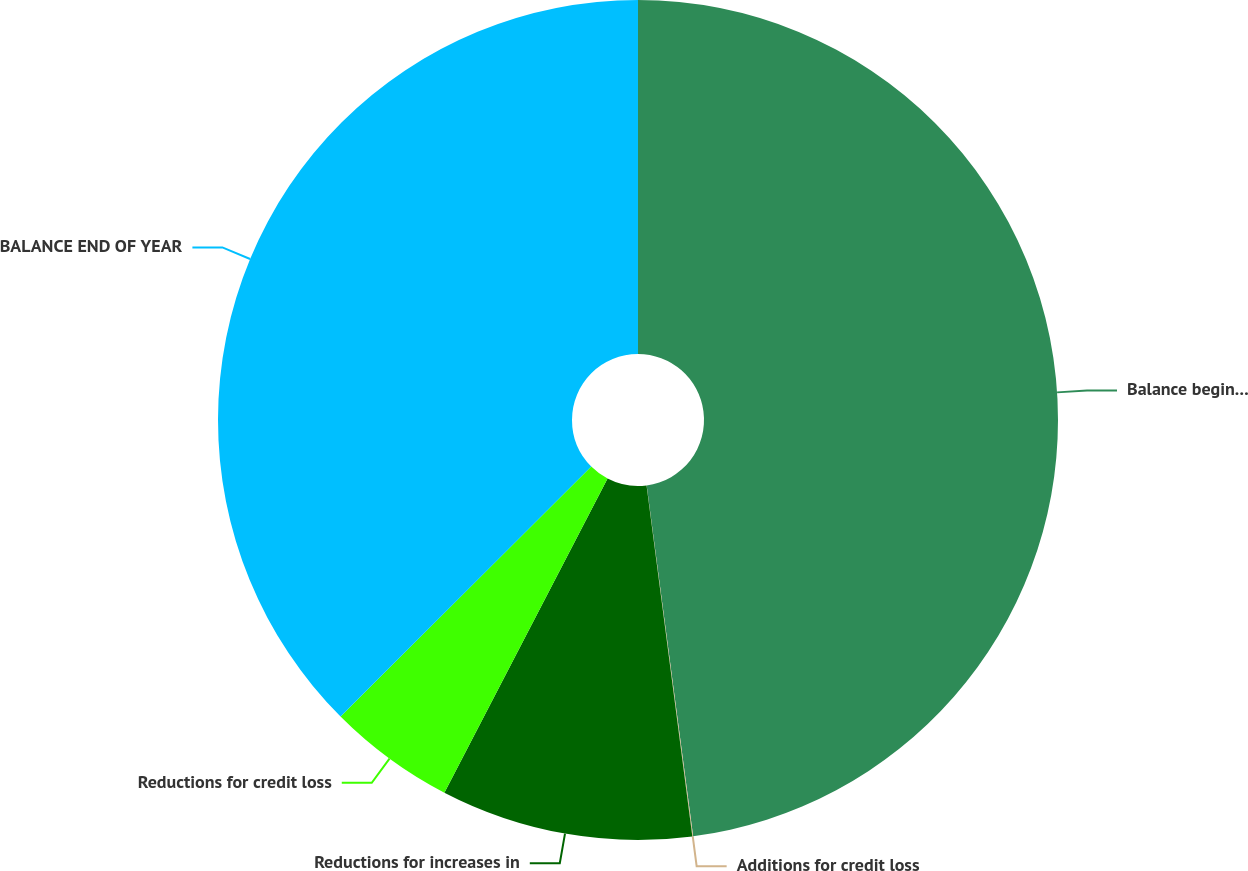<chart> <loc_0><loc_0><loc_500><loc_500><pie_chart><fcel>Balance beginning of year<fcel>Additions for credit loss<fcel>Reductions for increases in<fcel>Reductions for credit loss<fcel>BALANCE END OF YEAR<nl><fcel>47.9%<fcel>0.03%<fcel>9.69%<fcel>4.9%<fcel>37.47%<nl></chart> 